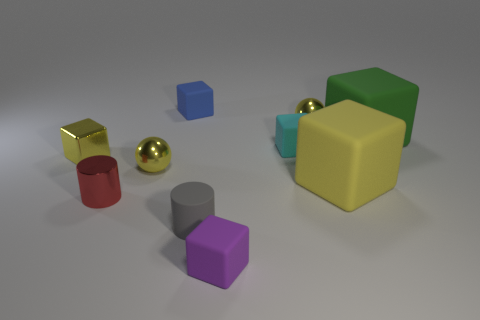What number of yellow things are both to the left of the tiny blue matte object and in front of the small yellow cube?
Provide a short and direct response. 1. How many other objects are the same size as the blue rubber object?
Offer a very short reply. 7. There is a ball that is behind the tiny yellow block; is it the same size as the green matte cube that is to the right of the metallic block?
Your response must be concise. No. What number of things are gray matte objects or objects that are in front of the large yellow matte thing?
Provide a short and direct response. 3. What size is the sphere to the right of the blue rubber block?
Offer a very short reply. Small. Are there fewer small metal spheres on the right side of the tiny matte cylinder than tiny metallic objects to the right of the small red metal cylinder?
Make the answer very short. Yes. What is the material of the yellow thing that is both to the left of the tiny cyan block and to the right of the red metal object?
Ensure brevity in your answer.  Metal. There is a large yellow matte thing that is in front of the yellow metal thing that is right of the gray matte cylinder; what shape is it?
Provide a short and direct response. Cube. What number of red objects are small objects or small cubes?
Provide a short and direct response. 1. There is a big green object; are there any cyan rubber cubes left of it?
Make the answer very short. Yes. 